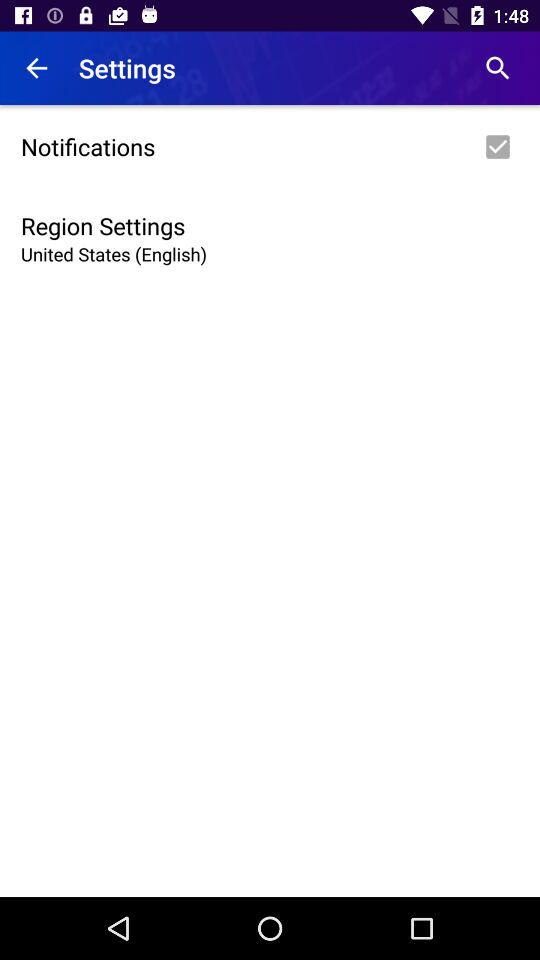How can users modify other settings in this menu? Users can modify other settings in this menu by navigating to different options such as 'Notifications'. Each section allows specific preferences adjustment like turning notifications on or off, or customizing alerts according to their needs. 